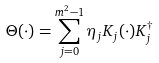Convert formula to latex. <formula><loc_0><loc_0><loc_500><loc_500>\Theta ( \cdot ) = \sum _ { j = 0 } ^ { m ^ { 2 } - 1 } \eta _ { j } K _ { j } ( \cdot ) K _ { j } ^ { \dagger }</formula> 